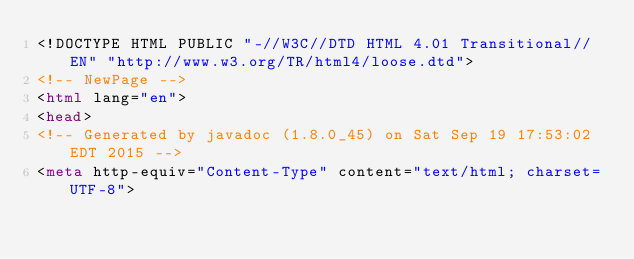<code> <loc_0><loc_0><loc_500><loc_500><_HTML_><!DOCTYPE HTML PUBLIC "-//W3C//DTD HTML 4.01 Transitional//EN" "http://www.w3.org/TR/html4/loose.dtd">
<!-- NewPage -->
<html lang="en">
<head>
<!-- Generated by javadoc (1.8.0_45) on Sat Sep 19 17:53:02 EDT 2015 -->
<meta http-equiv="Content-Type" content="text/html; charset=UTF-8"></code> 